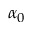Convert formula to latex. <formula><loc_0><loc_0><loc_500><loc_500>\alpha _ { 0 }</formula> 